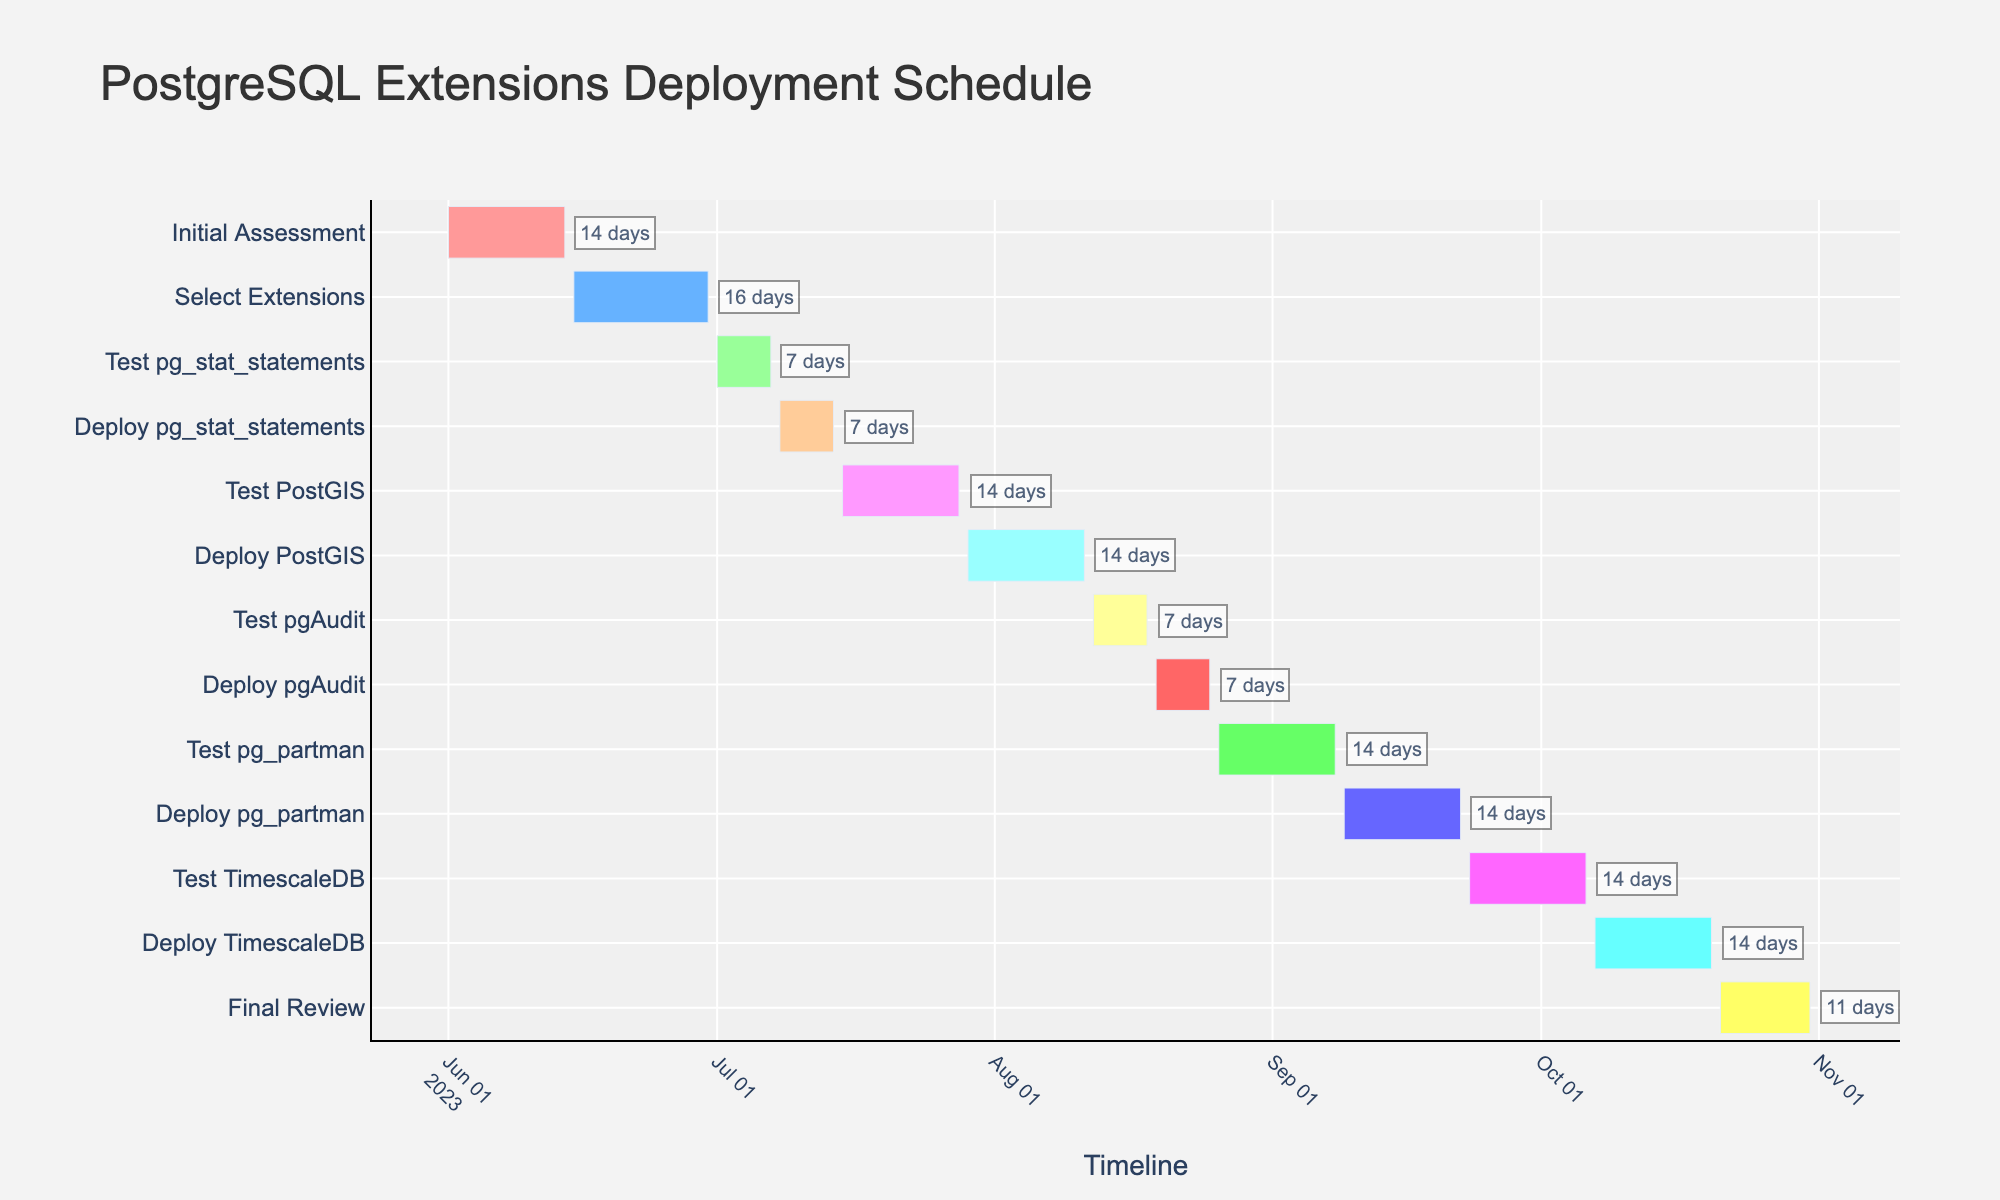What's the duration of the Initial Assessment task? Look for the Initial Assessment task on the Y-axis and check its respective duration annotated near the colored bar.
Answer: 14 days Which task starts on July 15, 2023? Locate July 15, 2023, on the X-axis and find the task that has its start date aligned with that date.
Answer: Test PostGIS How many tasks take exactly 7 days to complete? Look at the durations annotated near each task and count the number of tasks that have a duration of 7 days.
Answer: 4 tasks Which task has the longest duration? Compare the durations mentioned near the colored bars and identify the task with the maximum value.
Answer: Select Extensions What is the total duration of deploying all extensions combined? Identify all deployment tasks (Deploy pg_stat_statements, Deploy PostGIS, Deploy pgAudit, Deploy pg_partman, Deploy TimescaleDB) and sum their durations: 7 + 14 + 7 + 14 + 14.
Answer: 56 days Which tasks are colored with shades of green? Look at the color coding of the bars and note down the tasks that are shaded in green.
Answer: Test pg_stat_statements and Test pg_partman Are there any tasks overlapping in the timeline? If so, which ones? Examine the colored bars on the timeline for any overlaps in their start and end dates.
Answer: No tasks overlap What's the time gap between the end of the Initial Assessment and the start of Test pg_stat_statements? Calculate the days between June 14, 2023 (end of Initial Assessment) and July 1, 2023 (start of Test pg_stat_statements).
Answer: 17 days Which tasks lie entirely within the month of August 2023? Check the Start and End dates of tasks to see which ones fall completely within August 2023.
Answer: Test pgAudit and Deploy pgAudit What is the average duration of all testing tasks (excluding deployment tasks)? Sum the durations of testing tasks (Test pg_stat_statements, Test PostGIS, Test pgAudit, Test pg_partman, Test TimescaleDB) and divide by the number of testing tasks: (7 + 14 + 7 + 14 + 14) / 5.
Answer: 11.2 days 